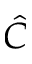Convert formula to latex. <formula><loc_0><loc_0><loc_500><loc_500>\hat { C }</formula> 